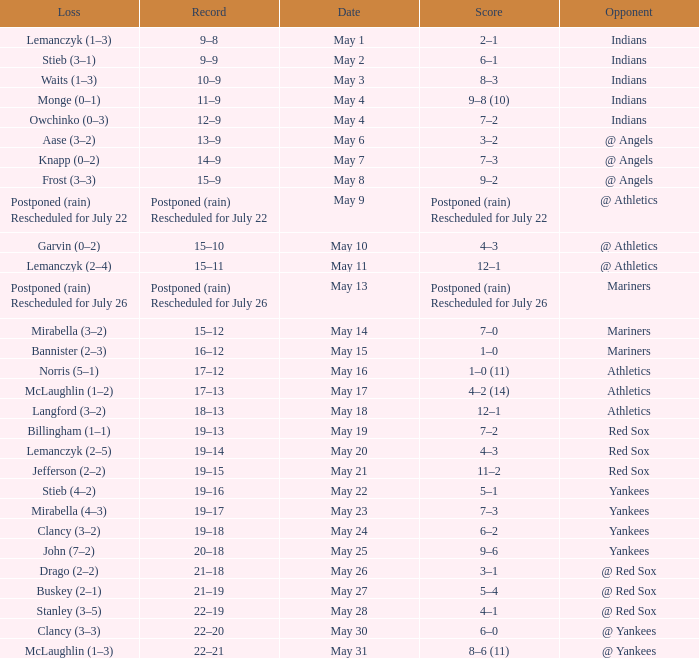Name the loss on may 22 Stieb (4–2). 